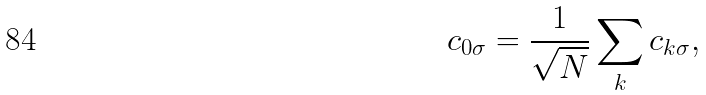<formula> <loc_0><loc_0><loc_500><loc_500>c _ { 0 \sigma } = \frac { 1 } { \sqrt { N } } \sum _ { k } c _ { k \sigma } ,</formula> 